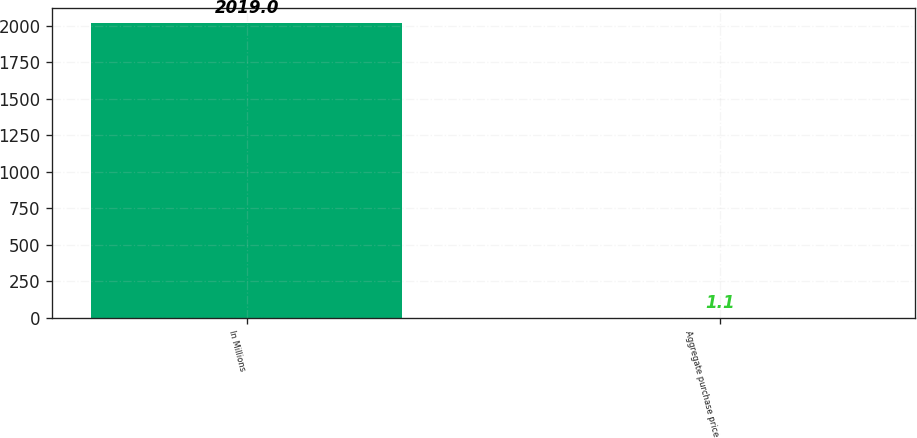<chart> <loc_0><loc_0><loc_500><loc_500><bar_chart><fcel>In Millions<fcel>Aggregate purchase price<nl><fcel>2019<fcel>1.1<nl></chart> 